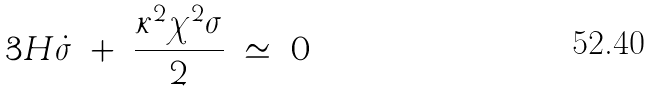Convert formula to latex. <formula><loc_0><loc_0><loc_500><loc_500>3 H \dot { \sigma } \ + \ \frac { \kappa ^ { 2 } \chi ^ { 2 } \sigma } { 2 } \ \simeq \ 0</formula> 